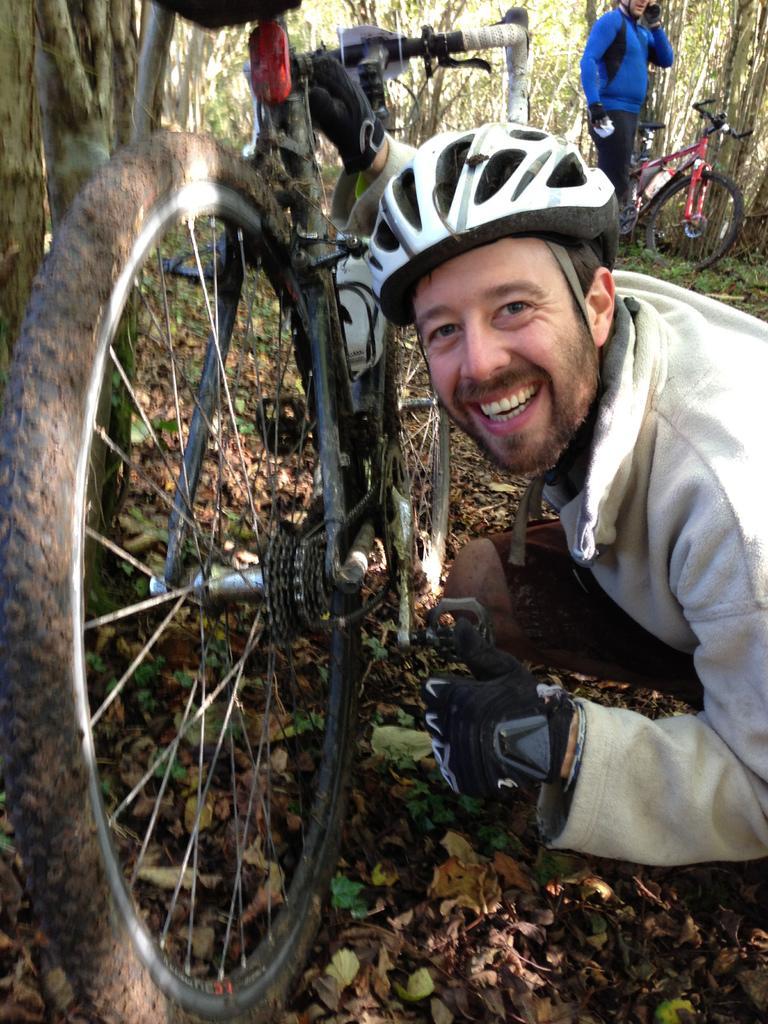How would you summarize this image in a sentence or two? In this picture we can see two men wore helmets and gloves where a man is smiling, bicycles and in the background we can see trees. 